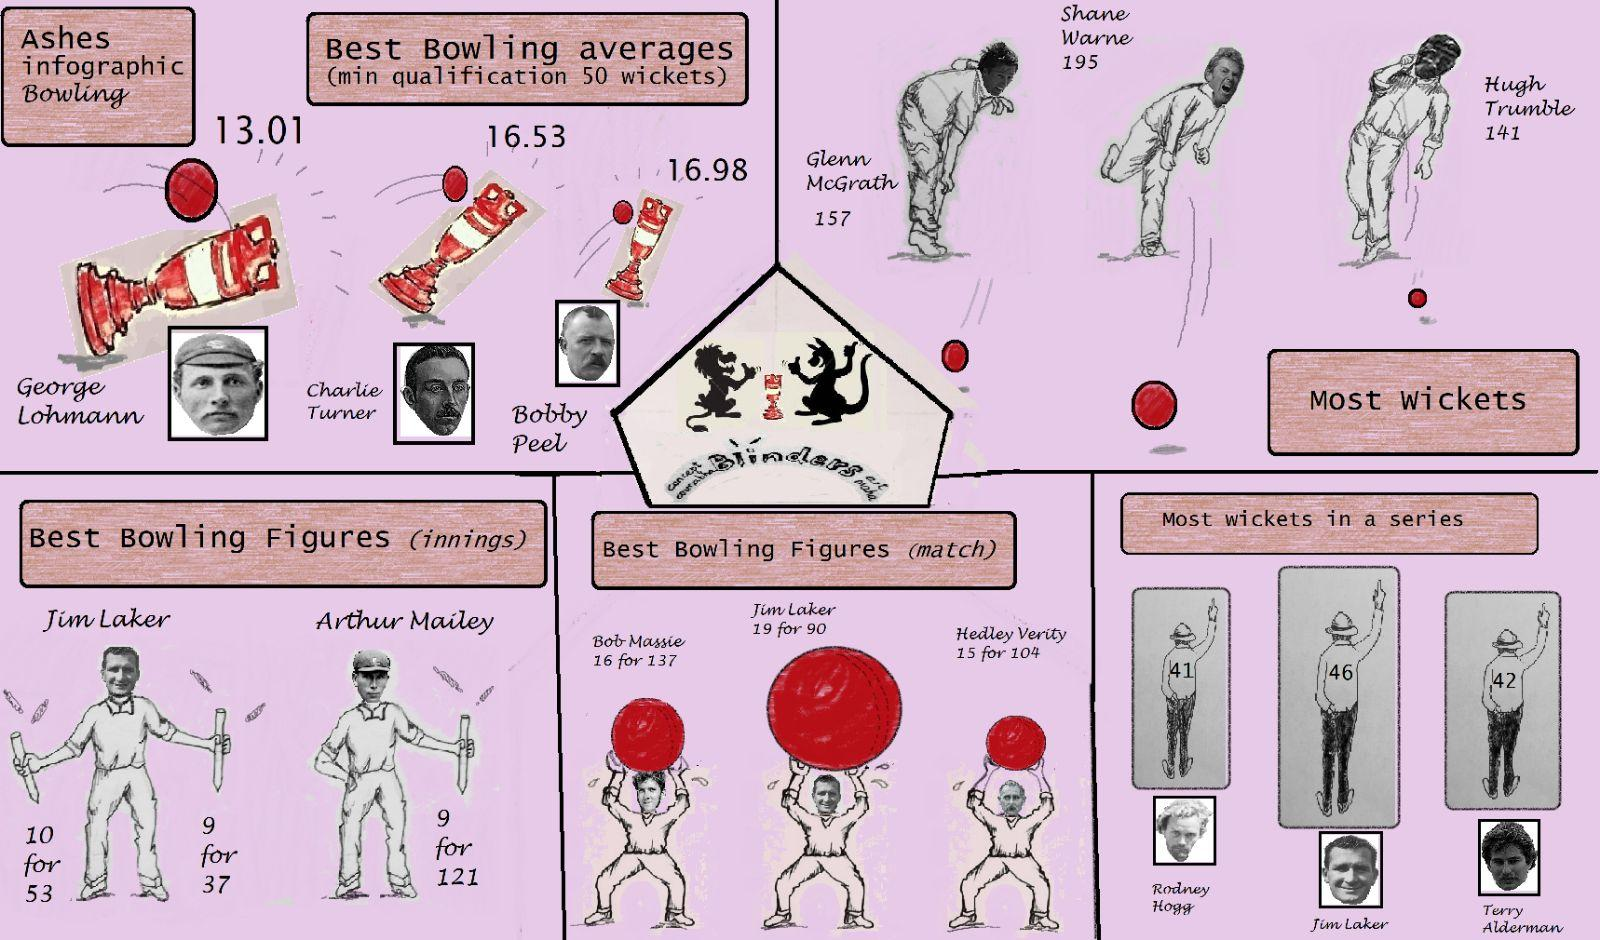Mention a couple of crucial points in this snapshot. The player who captured the most wickets was Shane Warne. In the Ashes series, Charlie Turner achieved the second-highest bowling average among all bowlers. In the history of cricket, there have been numerous talented players who have left an indelible mark on the game. One such player was Jim Laker, who was known for his exceptional bowling skills. It is said that in a series against England and Australia in 1956, Jim Laker had the best match bowling figures and most wickets, which cemented his place in cricket folklore. 